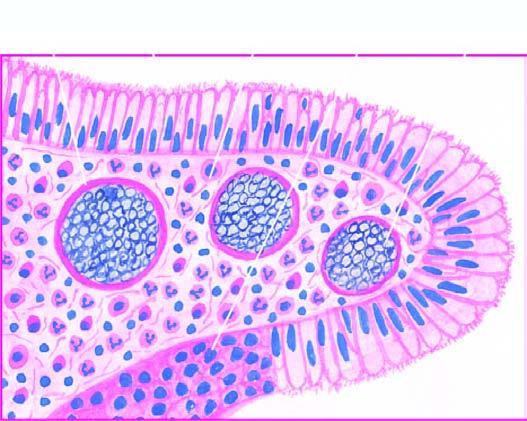what are the spores present in?
Answer the question using a single word or phrase. Sporangia as well as intermingled in the inflammatory cell infiltrate 